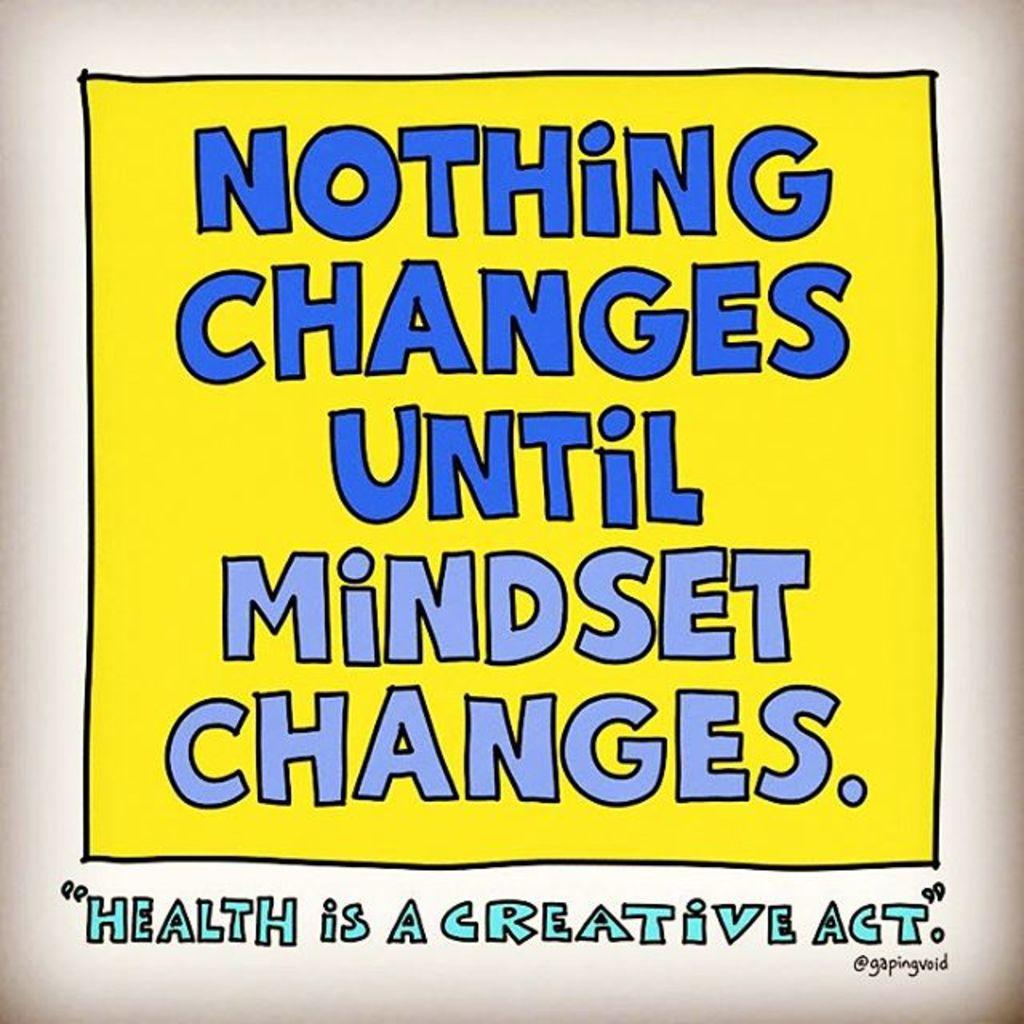<image>
Offer a succinct explanation of the picture presented. A sign states "Nothing Changes Until Mindset Changes." 